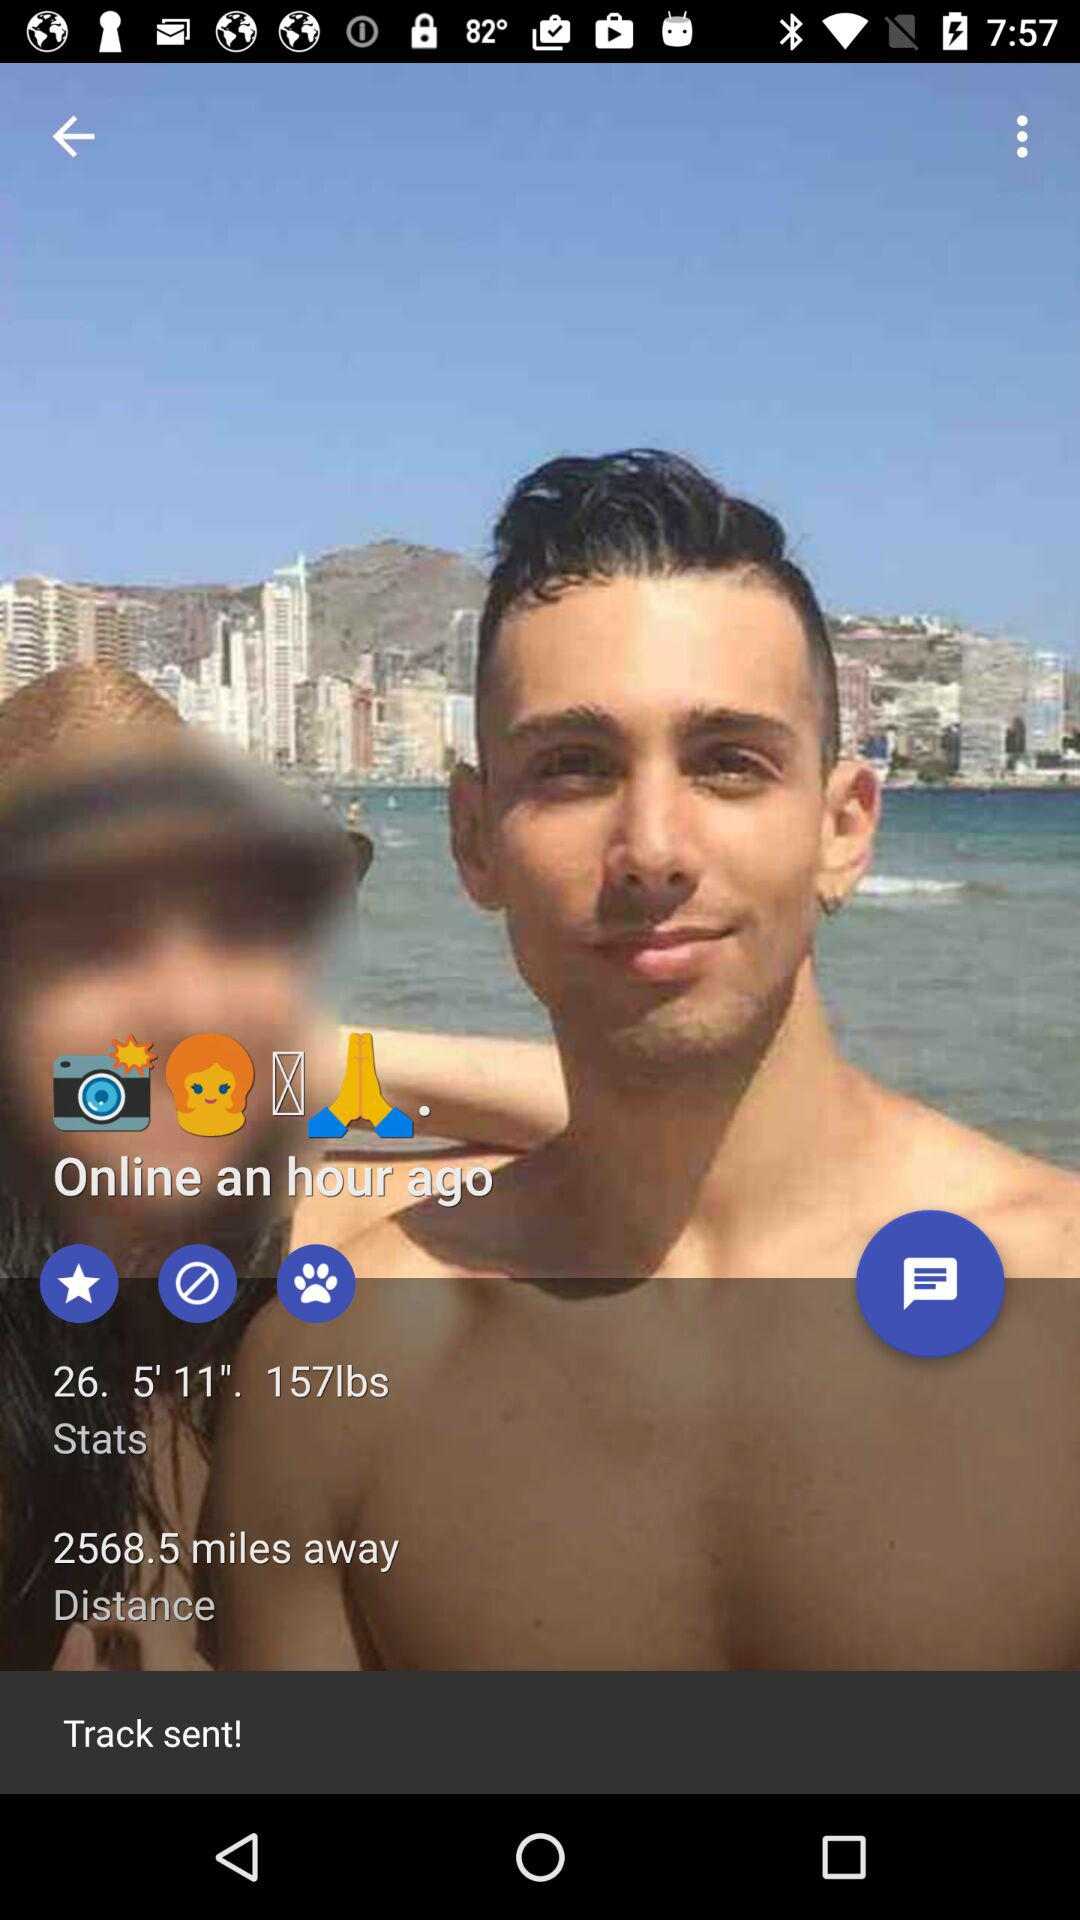How many photos are on the profile?
When the provided information is insufficient, respond with <no answer>. <no answer> 